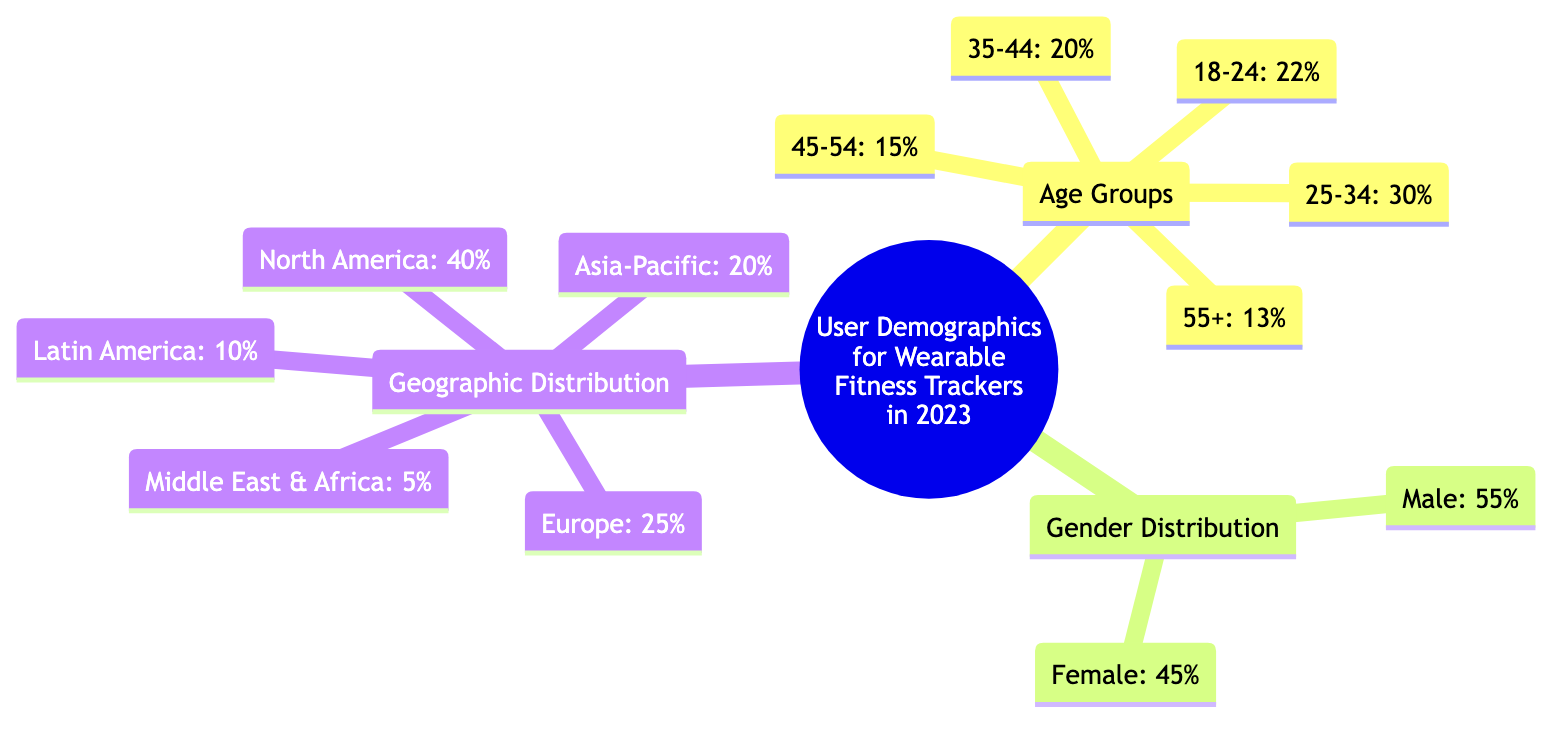What percentage of users are aged 25-34? The diagram indicates that in the Age Groups section, 25-34 is specified as having 30% of users in this demographic.
Answer: 30% What is the male to female ratio among wearable fitness tracker users? From the Gender Distribution section, we can see that males make up 55% and females 45%. This gives a ratio of 55:45.
Answer: 55:45 Which age group has the highest percentage of users? The Age Groups section highlights that the 25-34 age group has the highest percentage at 30%.
Answer: 25-34 What is the percentage of users in the Asia-Pacific region? The Geographic Distribution section notes that users in the Asia-Pacific region account for 20% of the total demographic.
Answer: 20% What region has the lowest percentage of wearable fitness tracker users? In the Geographic Distribution section, the Middle East & Africa region has the lowest percentage at 5%.
Answer: 5% If you combine the percentages of the 45-54 and 55+ age groups, what percentage do they represent? Add the percentages from the Age Groups: 15% for 45-54 and 13% for 55+, which equals 28%.
Answer: 28% What gender has a higher representation in wearable fitness tracker usage? By examining the Gender Distribution, males represent 55%, which is higher than the 45% represented by females.
Answer: Male How does the geographic distribution differ between North America and Latin America? Comparing the Geographic Distribution: North America has 40% of users while Latin America has 10%, indicating North America has a significantly higher representation.
Answer: North America has higher representation 